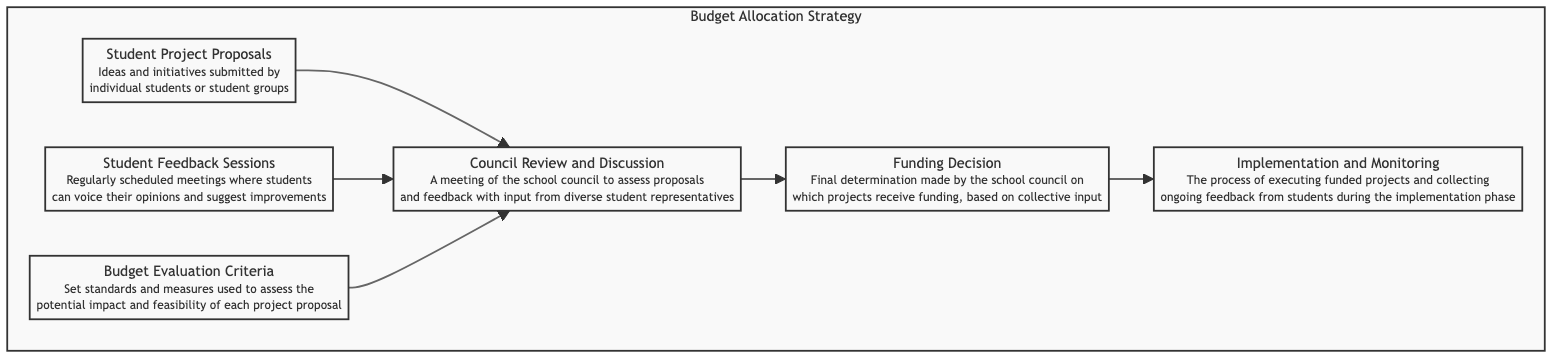What are the two initial stages of the budget allocation process? The two initial stages shown in the diagram are "Student Project Proposals" and "Student Feedback Sessions." These nodes are at the top of the flow chart and lead into the "Council Review and Discussion."
Answer: Student Project Proposals, Student Feedback Sessions How many nodes are present in the diagram? The diagram features six nodes: "Student Project Proposals," "Student Feedback Sessions," "Council Review and Discussion," "Budget Evaluation Criteria," "Funding Decision," and "Implementation and Monitoring."
Answer: Six What is the relationship between "Budget Evaluation Criteria" and "Council Review and Discussion"? The "Budget Evaluation Criteria" node leads into the "Council Review and Discussion" node, indicating that these criteria are considered during the review process. This relationship is shown through a directed edge in the flow chart.
Answer: Leads into What is the final output of the process depicted in this diagram? The final output of the process, as indicated in the diagram, is "Funding Decision," which reflects the choices made by the school council based on collective input and assessments.
Answer: Funding Decision Which node comes directly before "Implementation and Monitoring"? The node that comes directly before "Implementation and Monitoring" is "Funding Decision," as indicated by the flow from the funding decision leading into the implementation phase in the diagram.
Answer: Funding Decision How do student feedback sessions contribute to the council review? Student feedback sessions provide opinions and suggestions from students, which are taken into account during the "Council Review and Discussion," helping to inform the decisions made regarding project proposals. This input is essential for ensuring diverse student perspectives are considered.
Answer: Contribute opinions and suggestions What follows after "Council Review and Discussion"? After "Council Review and Discussion," the next step in the process is the "Funding Decision," where the school council makes determinations about which projects will receive funding based on the discussions and input gathered.
Answer: Funding Decision Which process involves executing funded projects? The process that involves executing funded projects is "Implementation and Monitoring," which follows the "Funding Decision," signifying the start of the project execution phase and feedback collection from students.
Answer: Implementation and Monitoring 